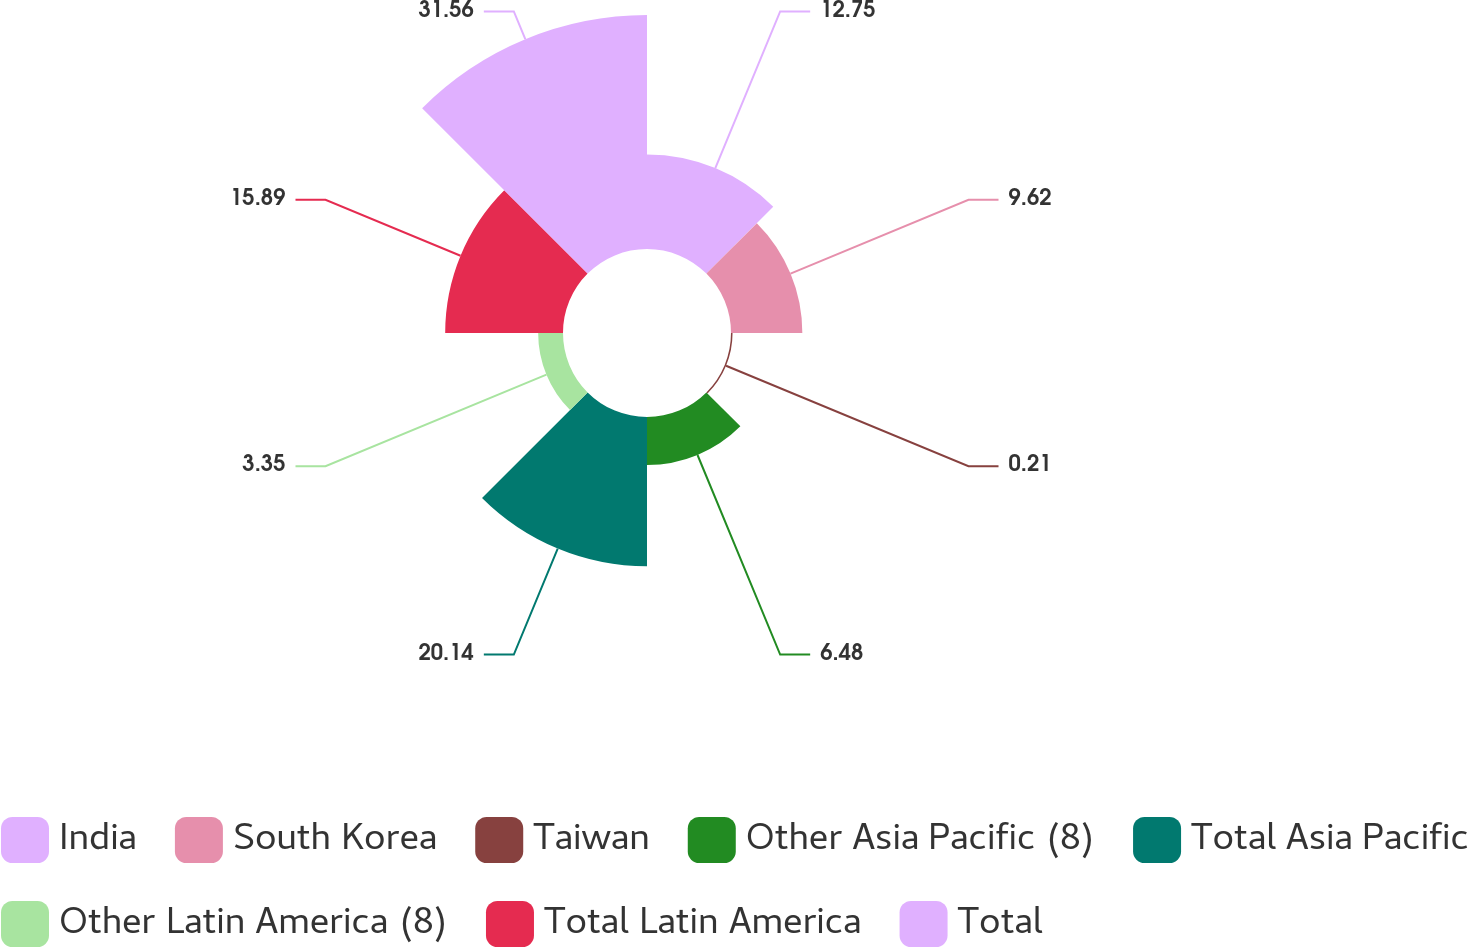Convert chart. <chart><loc_0><loc_0><loc_500><loc_500><pie_chart><fcel>India<fcel>South Korea<fcel>Taiwan<fcel>Other Asia Pacific (8)<fcel>Total Asia Pacific<fcel>Other Latin America (8)<fcel>Total Latin America<fcel>Total<nl><fcel>12.75%<fcel>9.62%<fcel>0.21%<fcel>6.48%<fcel>20.14%<fcel>3.35%<fcel>15.89%<fcel>31.56%<nl></chart> 